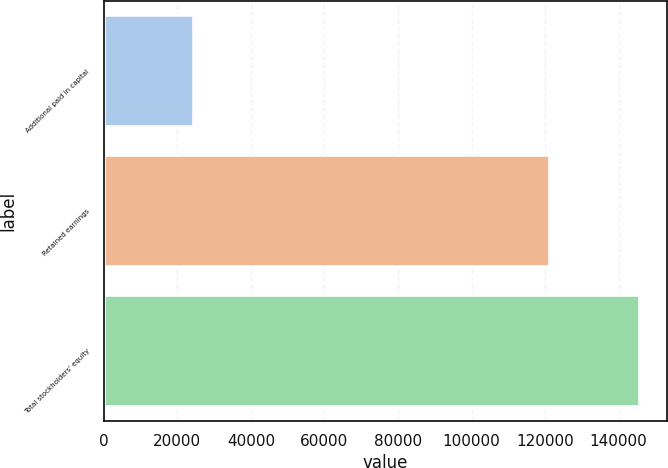Convert chart. <chart><loc_0><loc_0><loc_500><loc_500><bar_chart><fcel>Additional paid in capital<fcel>Retained earnings<fcel>Total stockholders' equity<nl><fcel>24575<fcel>121270<fcel>145845<nl></chart> 